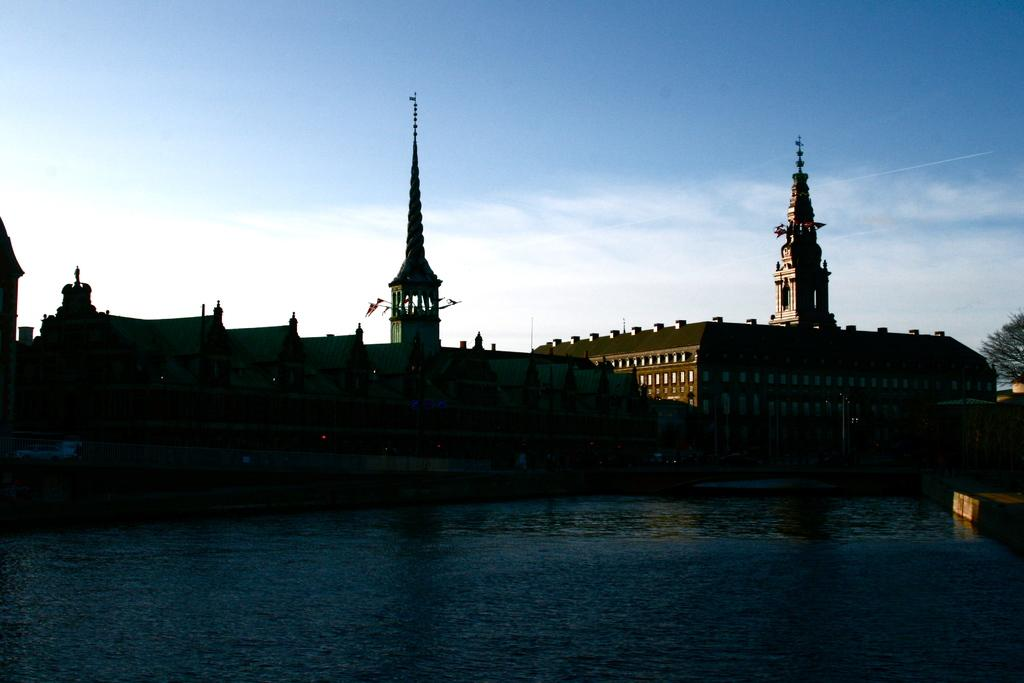What structures can be seen in the image? There are buildings in the image. What type of vegetation is on the right side of the image? There is a tree on the right side of the image. How would you describe the sky in the image? The sky is blue and cloudy in the image. What degree does the pen have in the image? There is no pen present in the image, so it cannot have a degree. 